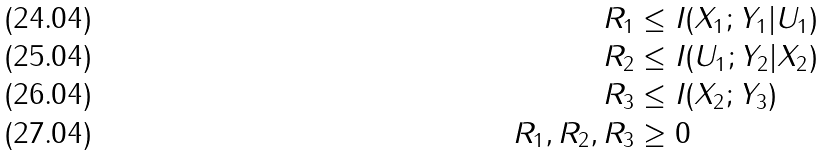Convert formula to latex. <formula><loc_0><loc_0><loc_500><loc_500>R _ { 1 } & \leq I ( X _ { 1 } ; Y _ { 1 } | U _ { 1 } ) \\ R _ { 2 } & \leq I ( U _ { 1 } ; Y _ { 2 } | X _ { 2 } ) \\ R _ { 3 } & \leq I ( X _ { 2 } ; Y _ { 3 } ) \\ R _ { 1 } , R _ { 2 } , R _ { 3 } & \geq 0</formula> 